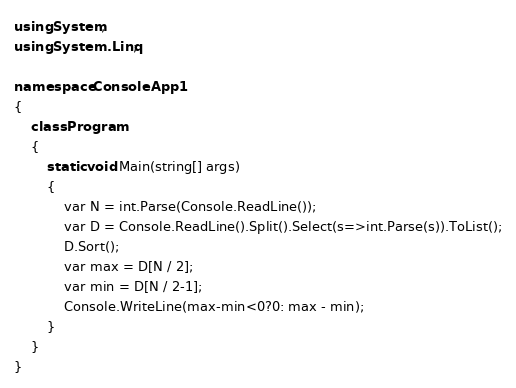<code> <loc_0><loc_0><loc_500><loc_500><_C#_>using System;
using System.Linq;

namespace ConsoleApp1
{
    class Program
    {
        static void Main(string[] args)
        {
            var N = int.Parse(Console.ReadLine());
            var D = Console.ReadLine().Split().Select(s=>int.Parse(s)).ToList();
            D.Sort();
            var max = D[N / 2];
            var min = D[N / 2-1];
            Console.WriteLine(max-min<0?0: max - min);
        }
    }
}
</code> 